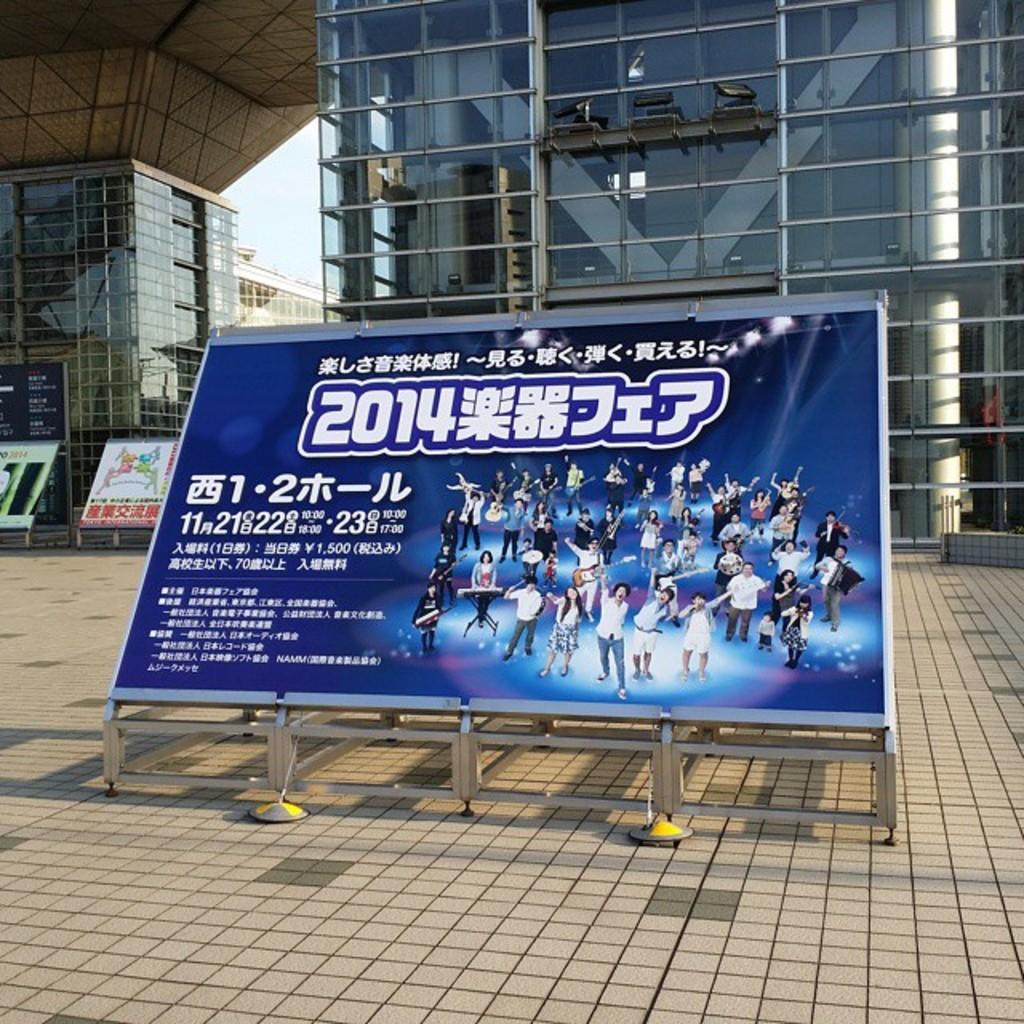<image>
Summarize the visual content of the image. A sign on a stand sits outside a glass building with numbers 11 and 21 written on it. 